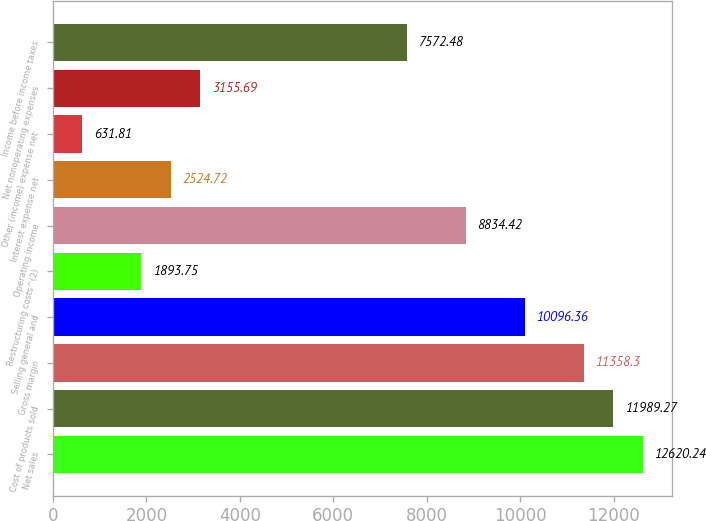<chart> <loc_0><loc_0><loc_500><loc_500><bar_chart><fcel>Net sales<fcel>Cost of products sold<fcel>Gross margin<fcel>Selling general and<fcel>Restructuring costs^(2)<fcel>Operating income<fcel>Interest expense net<fcel>Other (income) expense net<fcel>Net nonoperating expenses<fcel>Income before income taxes<nl><fcel>12620.2<fcel>11989.3<fcel>11358.3<fcel>10096.4<fcel>1893.75<fcel>8834.42<fcel>2524.72<fcel>631.81<fcel>3155.69<fcel>7572.48<nl></chart> 